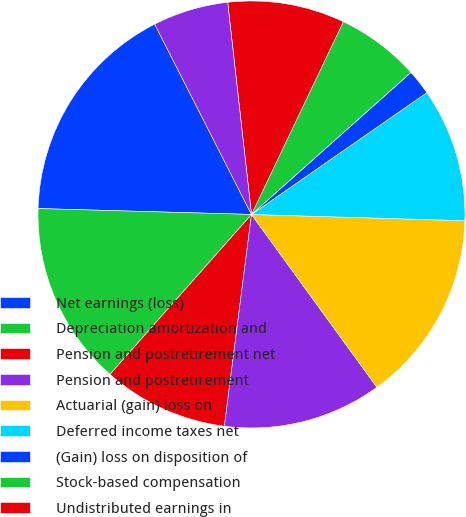<chart> <loc_0><loc_0><loc_500><loc_500><pie_chart><fcel>Net earnings (loss)<fcel>Depreciation amortization and<fcel>Pension and postretirement net<fcel>Pension and postretirement<fcel>Actuarial (gain) loss on<fcel>Deferred income taxes net<fcel>(Gain) loss on disposition of<fcel>Stock-based compensation<fcel>Undistributed earnings in<fcel>Other net<nl><fcel>17.07%<fcel>13.91%<fcel>9.5%<fcel>12.02%<fcel>14.54%<fcel>10.13%<fcel>1.92%<fcel>6.34%<fcel>8.86%<fcel>5.71%<nl></chart> 